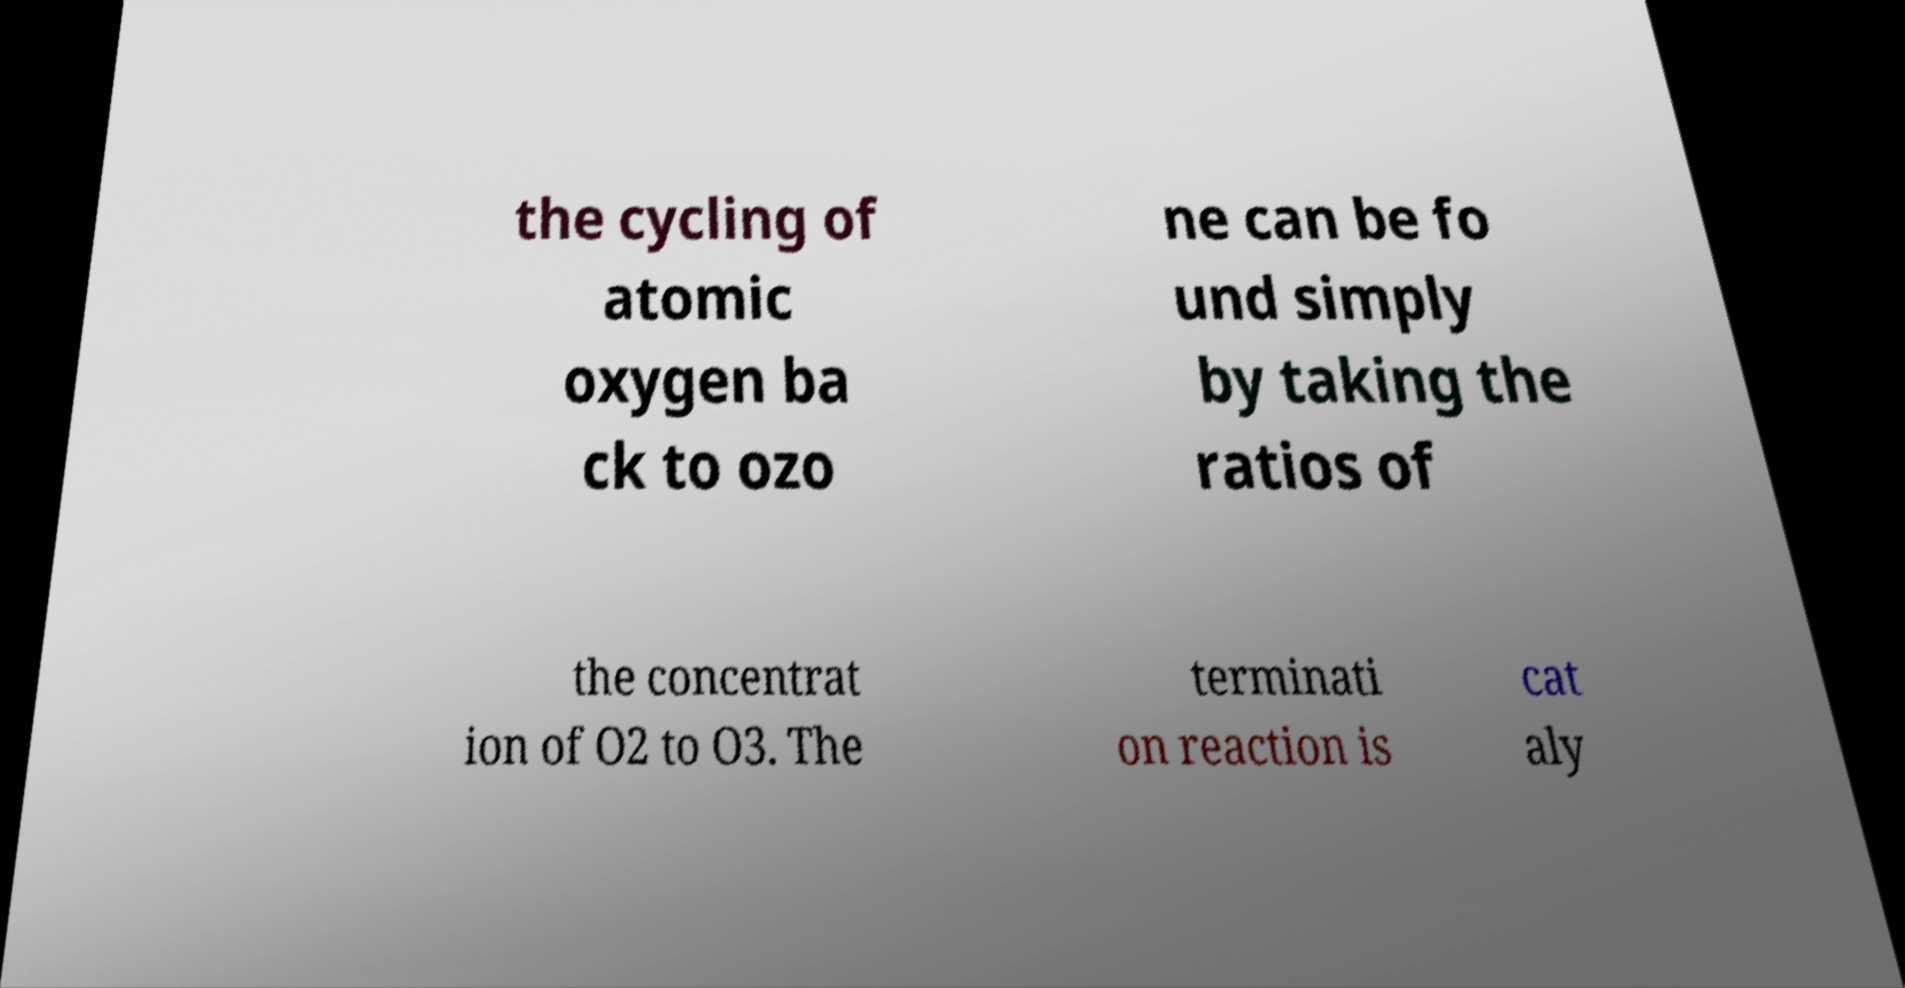There's text embedded in this image that I need extracted. Can you transcribe it verbatim? the cycling of atomic oxygen ba ck to ozo ne can be fo und simply by taking the ratios of the concentrat ion of O2 to O3. The terminati on reaction is cat aly 